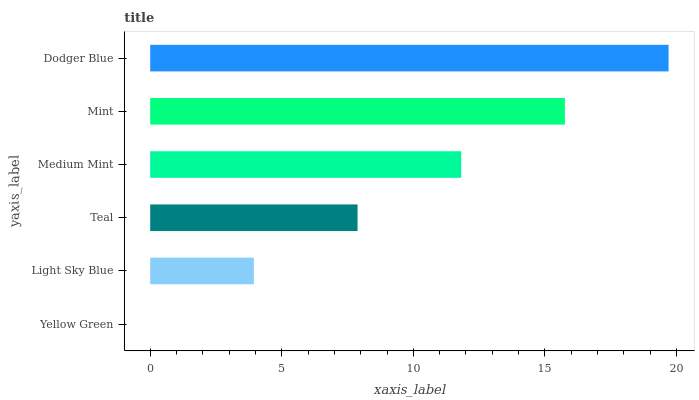Is Yellow Green the minimum?
Answer yes or no. Yes. Is Dodger Blue the maximum?
Answer yes or no. Yes. Is Light Sky Blue the minimum?
Answer yes or no. No. Is Light Sky Blue the maximum?
Answer yes or no. No. Is Light Sky Blue greater than Yellow Green?
Answer yes or no. Yes. Is Yellow Green less than Light Sky Blue?
Answer yes or no. Yes. Is Yellow Green greater than Light Sky Blue?
Answer yes or no. No. Is Light Sky Blue less than Yellow Green?
Answer yes or no. No. Is Medium Mint the high median?
Answer yes or no. Yes. Is Teal the low median?
Answer yes or no. Yes. Is Dodger Blue the high median?
Answer yes or no. No. Is Light Sky Blue the low median?
Answer yes or no. No. 